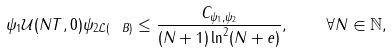<formula> <loc_0><loc_0><loc_500><loc_500>\| \psi _ { 1 } \mathcal { U } ( N T , 0 ) \psi _ { 2 } \| _ { \mathcal { L } ( { \ B } ) } \leq \frac { C _ { \psi _ { 1 } , \psi _ { 2 } } } { ( N + 1 ) \ln ^ { 2 } ( N + e ) } , \quad \forall N \in \mathbb { N } ,</formula> 